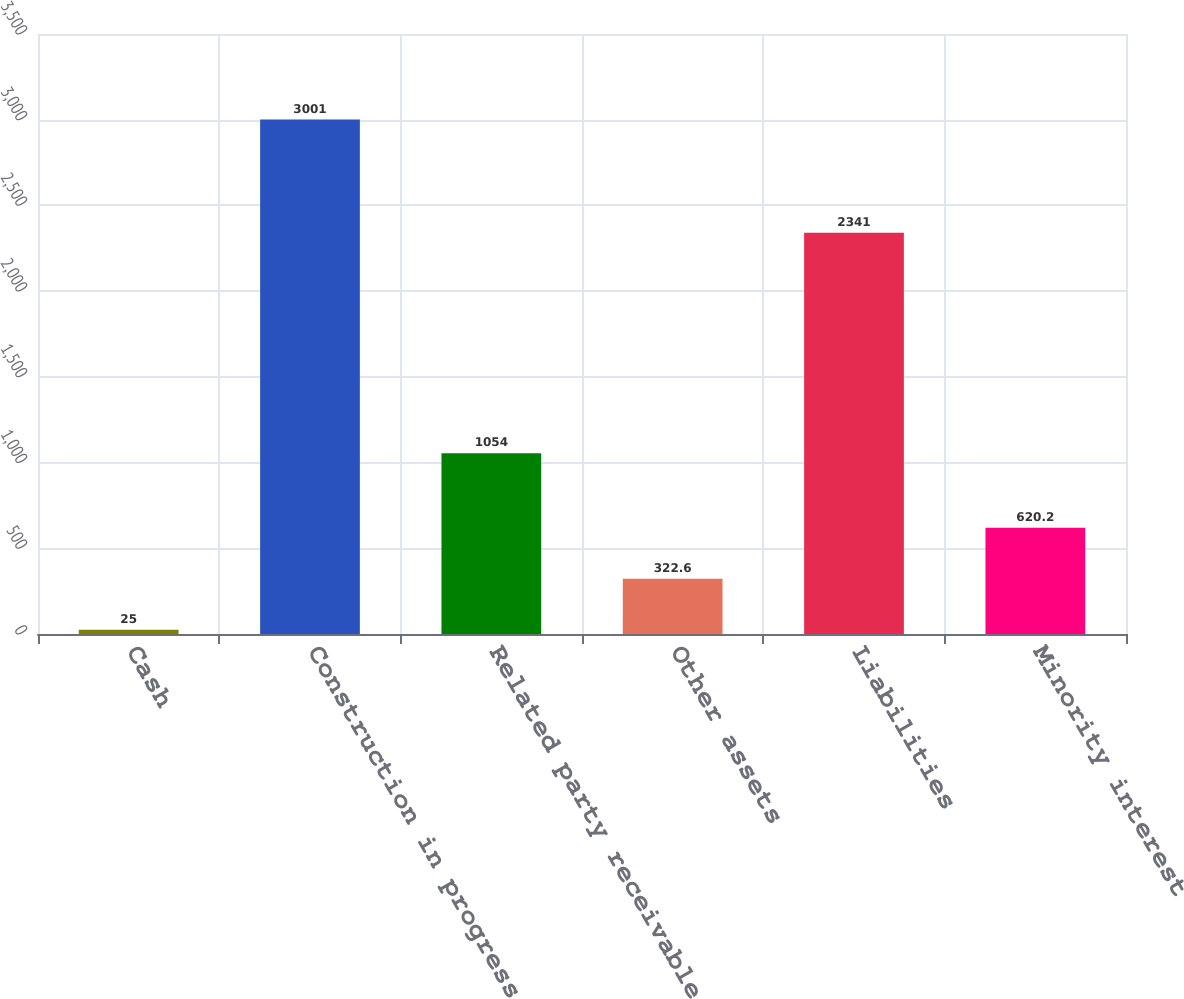<chart> <loc_0><loc_0><loc_500><loc_500><bar_chart><fcel>Cash<fcel>Construction in progress<fcel>Related party receivable<fcel>Other assets<fcel>Liabilities<fcel>Minority interest<nl><fcel>25<fcel>3001<fcel>1054<fcel>322.6<fcel>2341<fcel>620.2<nl></chart> 